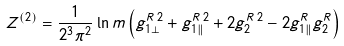Convert formula to latex. <formula><loc_0><loc_0><loc_500><loc_500>Z ^ { ( 2 ) } = \frac { 1 } { 2 ^ { 3 } \pi ^ { 2 } } \ln m \left ( g _ { 1 \perp } ^ { R \, 2 } + g _ { 1 \| } ^ { R \, 2 } + 2 g _ { 2 } ^ { R \, 2 } - 2 g _ { 1 \| } ^ { R } g _ { 2 } ^ { R } \right )</formula> 